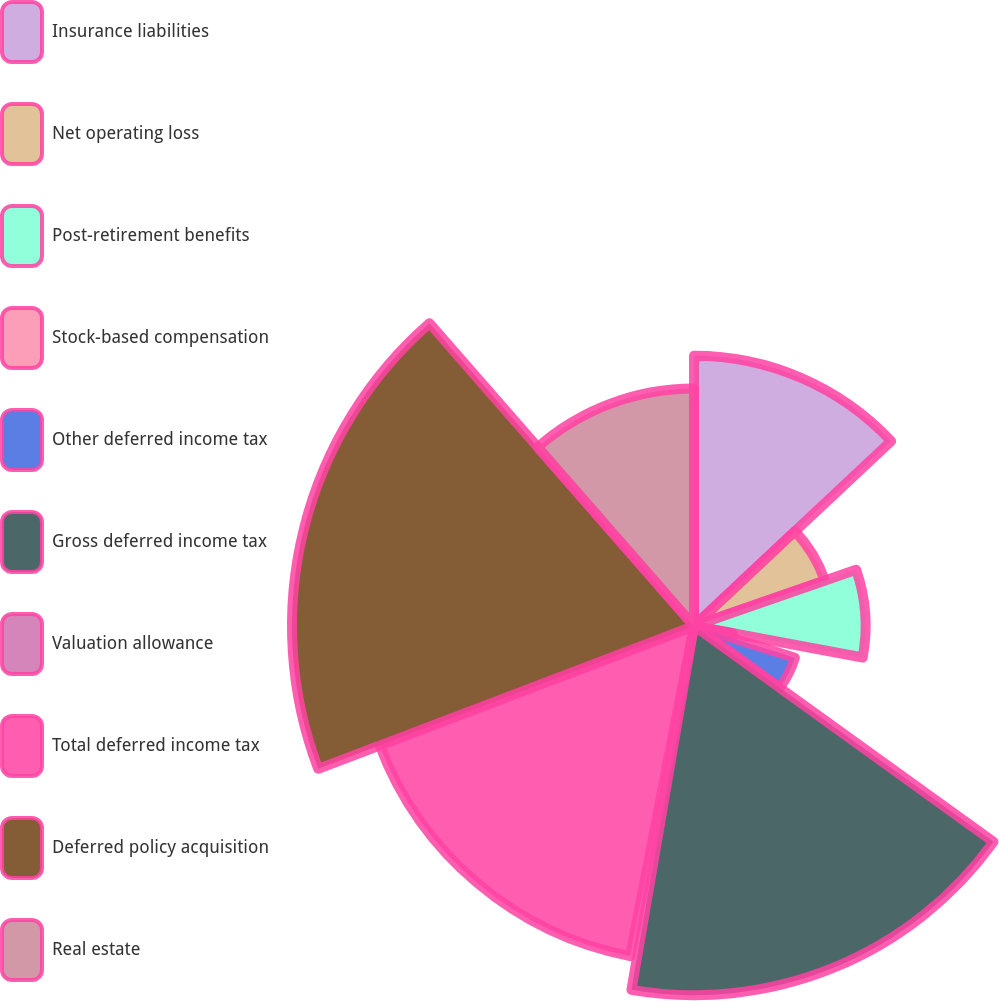Convert chart to OTSL. <chart><loc_0><loc_0><loc_500><loc_500><pie_chart><fcel>Insurance liabilities<fcel>Net operating loss<fcel>Post-retirement benefits<fcel>Stock-based compensation<fcel>Other deferred income tax<fcel>Gross deferred income tax<fcel>Valuation allowance<fcel>Total deferred income tax<fcel>Deferred policy acquisition<fcel>Real estate<nl><fcel>13.01%<fcel>6.67%<fcel>8.26%<fcel>1.91%<fcel>5.09%<fcel>17.77%<fcel>0.33%<fcel>16.18%<fcel>19.35%<fcel>11.43%<nl></chart> 